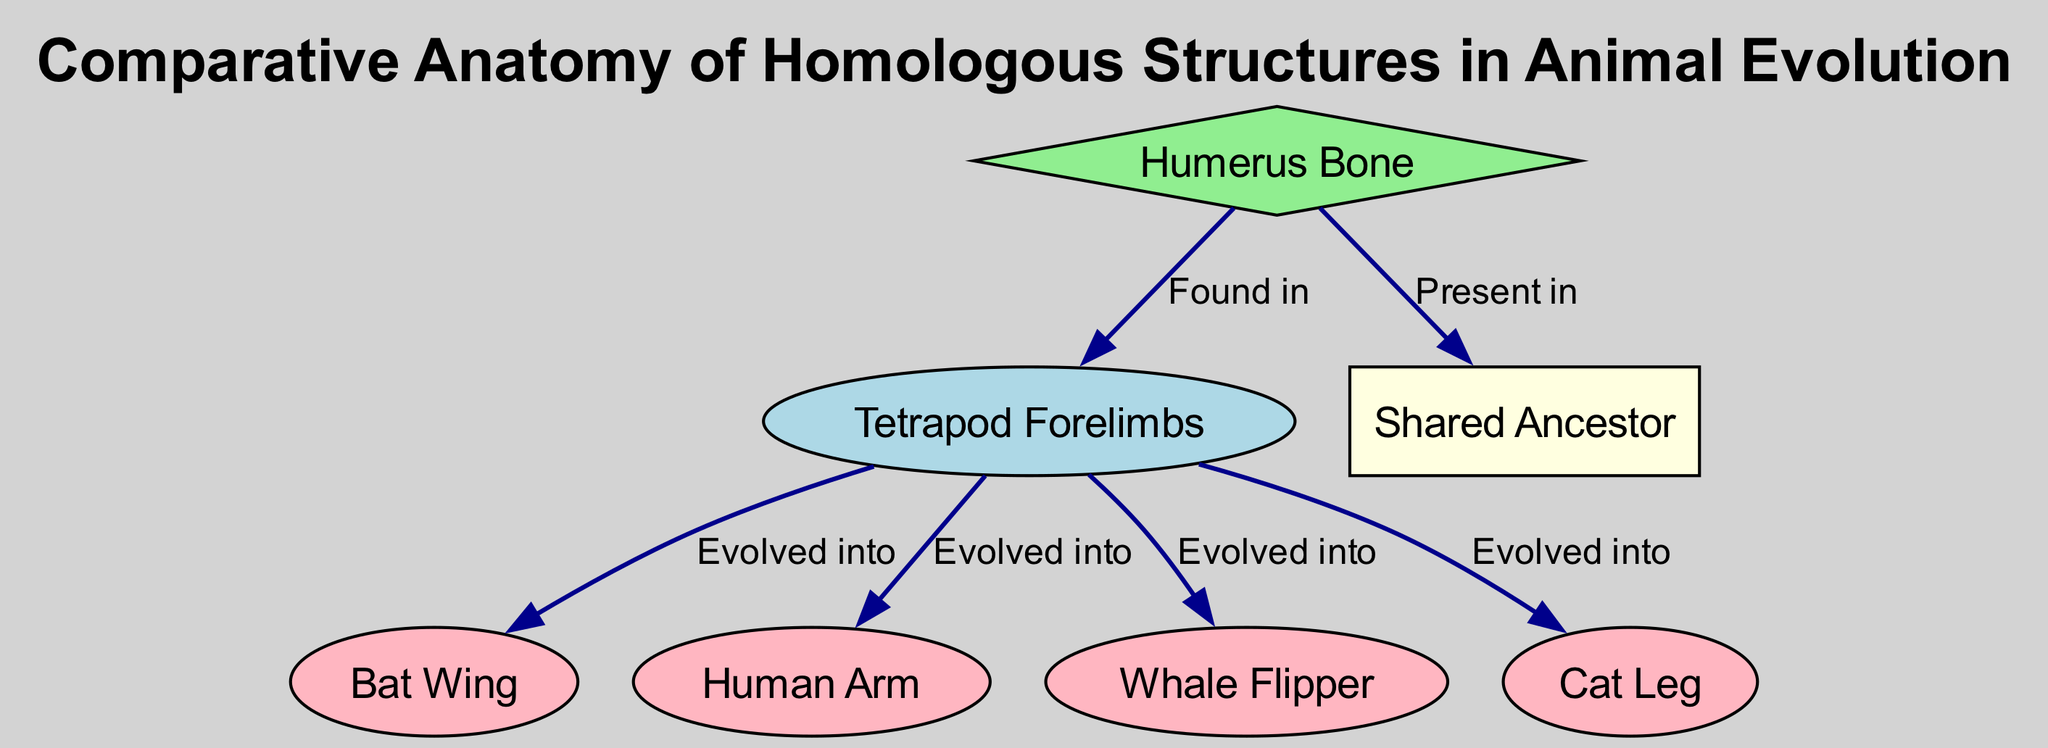What is the primary bone illustrated at the top of the diagram? The diagram indicates that the primary bone illustrated at the top is the "Humerus Bone." This is identified as the node labeled "Humerus Bone," found at the top of the diagram.
Answer: Humerus Bone How many different types of forelimbs are shown as evolved forms in the diagram? The diagram lists four types of evolved forelimbs stemming from the "Tetrapod Forelimbs": "Bat Wing," "Human Arm," "Whale Flipper," and "Cat Leg." Hence, counting these, there are four different types depicted.
Answer: 4 Which structure is described as a "common ancestor of modern tetrapods"? The diagram includes a node labeled "Shared Ancestor," and the description states that it represents the "common ancestor of modern tetrapods." Thus, that is the identified structure in the diagram.
Answer: Shared Ancestor What relationship exists between the Humerus Bone and the Shared Ancestor? According to the diagram, the relationship stated is that the "Humerus Bone" is "Present in" the "Shared Ancestor." This means that the structure of the Humerus Bone can be traced back to the shared ancestor of modern tetrapods.
Answer: Present in Which forelimb evolved specifically for flight? In the diagram, the "Bat Wing" is identified as the structure that evolved specifically for flight, as indicated by its direct connection to the "Tetrapod Forelimbs" labeled "Evolved into."
Answer: Bat Wing What type of structure is depicted at the bottom of the diagram, and what does it represent? At the bottom of the diagram, the "Shared Ancestor" is categorized as a box shape, which distinguishes it from the other nodes and indicates that it represents the common lineage from which other structures evolved.
Answer: Box Which limb structure is adapted for manipulation in humans? The diagram clearly shows the "Human Arm" as the structure that is adapted specifically for manipulation in humans. This is evident from the connection to the "Tetrapod Forelimbs" and its specific labeling.
Answer: Human Arm What color was used to represent the Tetrapod Forelimbs in the diagram? The "Tetrapod Forelimbs" node is colored light blue in the diagram, as indicated in the visualization details regarding node colors.
Answer: Light blue Which forelimb structure evolved into the Whale Flipper? The diagram depicts that the "Tetrapod Forelimbs" evolved into the "Whale Flipper," showing this direct evolutionary relationship between them.
Answer: Whale Flipper 